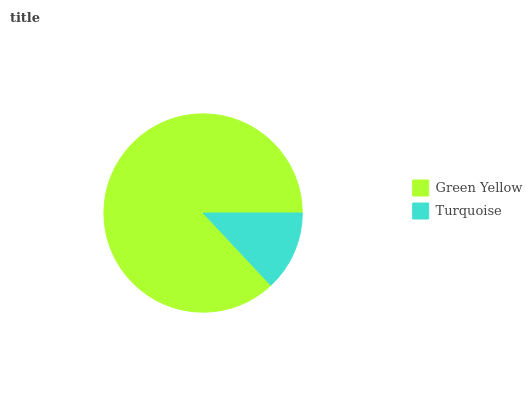Is Turquoise the minimum?
Answer yes or no. Yes. Is Green Yellow the maximum?
Answer yes or no. Yes. Is Turquoise the maximum?
Answer yes or no. No. Is Green Yellow greater than Turquoise?
Answer yes or no. Yes. Is Turquoise less than Green Yellow?
Answer yes or no. Yes. Is Turquoise greater than Green Yellow?
Answer yes or no. No. Is Green Yellow less than Turquoise?
Answer yes or no. No. Is Green Yellow the high median?
Answer yes or no. Yes. Is Turquoise the low median?
Answer yes or no. Yes. Is Turquoise the high median?
Answer yes or no. No. Is Green Yellow the low median?
Answer yes or no. No. 